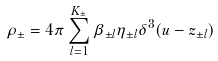Convert formula to latex. <formula><loc_0><loc_0><loc_500><loc_500>\rho _ { \pm } = 4 \pi \sum _ { l = 1 } ^ { K _ { \pm } } \beta _ { \pm l } \eta _ { \pm l } \delta ^ { 3 } ( u - z _ { \pm l } )</formula> 